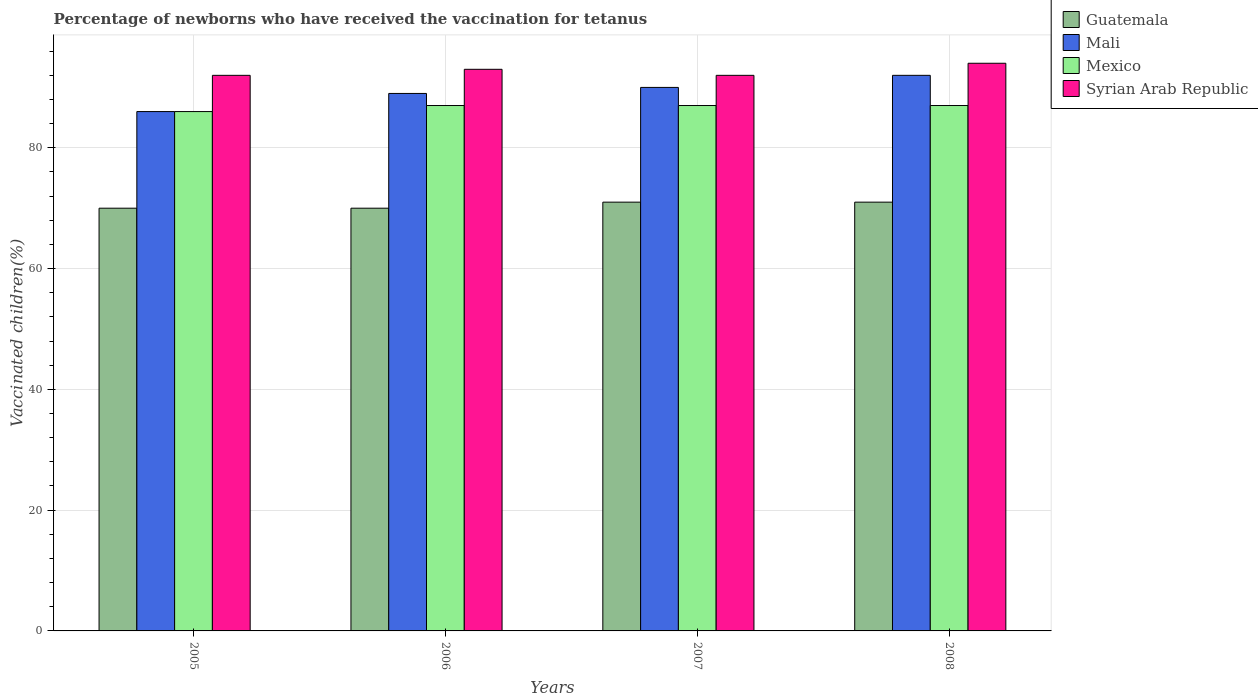How many groups of bars are there?
Keep it short and to the point. 4. Are the number of bars on each tick of the X-axis equal?
Ensure brevity in your answer.  Yes. How many bars are there on the 4th tick from the right?
Your response must be concise. 4. What is the label of the 3rd group of bars from the left?
Give a very brief answer. 2007. What is the percentage of vaccinated children in Guatemala in 2005?
Make the answer very short. 70. Across all years, what is the maximum percentage of vaccinated children in Guatemala?
Provide a short and direct response. 71. Across all years, what is the minimum percentage of vaccinated children in Mexico?
Provide a short and direct response. 86. In which year was the percentage of vaccinated children in Guatemala maximum?
Offer a terse response. 2007. What is the total percentage of vaccinated children in Mexico in the graph?
Keep it short and to the point. 347. What is the difference between the percentage of vaccinated children in Mali in 2007 and the percentage of vaccinated children in Syrian Arab Republic in 2005?
Provide a succinct answer. -2. What is the average percentage of vaccinated children in Mali per year?
Your response must be concise. 89.25. In the year 2007, what is the difference between the percentage of vaccinated children in Mexico and percentage of vaccinated children in Mali?
Give a very brief answer. -3. What is the ratio of the percentage of vaccinated children in Syrian Arab Republic in 2006 to that in 2008?
Ensure brevity in your answer.  0.99. Is the difference between the percentage of vaccinated children in Mexico in 2007 and 2008 greater than the difference between the percentage of vaccinated children in Mali in 2007 and 2008?
Your answer should be very brief. Yes. What is the difference between the highest and the second highest percentage of vaccinated children in Syrian Arab Republic?
Make the answer very short. 1. What is the difference between the highest and the lowest percentage of vaccinated children in Mexico?
Your answer should be very brief. 1. In how many years, is the percentage of vaccinated children in Syrian Arab Republic greater than the average percentage of vaccinated children in Syrian Arab Republic taken over all years?
Offer a terse response. 2. What does the 3rd bar from the left in 2007 represents?
Offer a very short reply. Mexico. What does the 3rd bar from the right in 2007 represents?
Offer a very short reply. Mali. Are all the bars in the graph horizontal?
Your response must be concise. No. Are the values on the major ticks of Y-axis written in scientific E-notation?
Offer a terse response. No. Does the graph contain any zero values?
Offer a terse response. No. Where does the legend appear in the graph?
Offer a very short reply. Top right. How many legend labels are there?
Provide a short and direct response. 4. What is the title of the graph?
Offer a very short reply. Percentage of newborns who have received the vaccination for tetanus. What is the label or title of the Y-axis?
Make the answer very short. Vaccinated children(%). What is the Vaccinated children(%) in Guatemala in 2005?
Your answer should be compact. 70. What is the Vaccinated children(%) in Mali in 2005?
Keep it short and to the point. 86. What is the Vaccinated children(%) in Mexico in 2005?
Offer a terse response. 86. What is the Vaccinated children(%) of Syrian Arab Republic in 2005?
Offer a terse response. 92. What is the Vaccinated children(%) in Guatemala in 2006?
Your answer should be compact. 70. What is the Vaccinated children(%) of Mali in 2006?
Offer a very short reply. 89. What is the Vaccinated children(%) in Mexico in 2006?
Offer a very short reply. 87. What is the Vaccinated children(%) of Syrian Arab Republic in 2006?
Keep it short and to the point. 93. What is the Vaccinated children(%) in Guatemala in 2007?
Offer a terse response. 71. What is the Vaccinated children(%) of Mali in 2007?
Your answer should be very brief. 90. What is the Vaccinated children(%) in Mexico in 2007?
Your response must be concise. 87. What is the Vaccinated children(%) in Syrian Arab Republic in 2007?
Ensure brevity in your answer.  92. What is the Vaccinated children(%) of Guatemala in 2008?
Give a very brief answer. 71. What is the Vaccinated children(%) in Mali in 2008?
Your answer should be very brief. 92. What is the Vaccinated children(%) in Syrian Arab Republic in 2008?
Offer a very short reply. 94. Across all years, what is the maximum Vaccinated children(%) of Guatemala?
Provide a short and direct response. 71. Across all years, what is the maximum Vaccinated children(%) of Mali?
Ensure brevity in your answer.  92. Across all years, what is the maximum Vaccinated children(%) in Syrian Arab Republic?
Provide a short and direct response. 94. Across all years, what is the minimum Vaccinated children(%) in Syrian Arab Republic?
Offer a very short reply. 92. What is the total Vaccinated children(%) of Guatemala in the graph?
Provide a succinct answer. 282. What is the total Vaccinated children(%) of Mali in the graph?
Your response must be concise. 357. What is the total Vaccinated children(%) of Mexico in the graph?
Keep it short and to the point. 347. What is the total Vaccinated children(%) of Syrian Arab Republic in the graph?
Your response must be concise. 371. What is the difference between the Vaccinated children(%) in Guatemala in 2005 and that in 2006?
Give a very brief answer. 0. What is the difference between the Vaccinated children(%) in Mexico in 2005 and that in 2006?
Provide a short and direct response. -1. What is the difference between the Vaccinated children(%) of Syrian Arab Republic in 2005 and that in 2006?
Give a very brief answer. -1. What is the difference between the Vaccinated children(%) in Guatemala in 2005 and that in 2007?
Offer a very short reply. -1. What is the difference between the Vaccinated children(%) in Mexico in 2005 and that in 2007?
Make the answer very short. -1. What is the difference between the Vaccinated children(%) in Mexico in 2005 and that in 2008?
Offer a very short reply. -1. What is the difference between the Vaccinated children(%) of Guatemala in 2006 and that in 2007?
Provide a succinct answer. -1. What is the difference between the Vaccinated children(%) of Mali in 2006 and that in 2007?
Your answer should be very brief. -1. What is the difference between the Vaccinated children(%) of Mali in 2006 and that in 2008?
Your answer should be compact. -3. What is the difference between the Vaccinated children(%) in Syrian Arab Republic in 2006 and that in 2008?
Provide a succinct answer. -1. What is the difference between the Vaccinated children(%) in Guatemala in 2007 and that in 2008?
Provide a short and direct response. 0. What is the difference between the Vaccinated children(%) in Mali in 2007 and that in 2008?
Provide a succinct answer. -2. What is the difference between the Vaccinated children(%) in Guatemala in 2005 and the Vaccinated children(%) in Mexico in 2006?
Keep it short and to the point. -17. What is the difference between the Vaccinated children(%) in Guatemala in 2005 and the Vaccinated children(%) in Syrian Arab Republic in 2006?
Ensure brevity in your answer.  -23. What is the difference between the Vaccinated children(%) of Mali in 2005 and the Vaccinated children(%) of Mexico in 2006?
Provide a succinct answer. -1. What is the difference between the Vaccinated children(%) in Mali in 2005 and the Vaccinated children(%) in Syrian Arab Republic in 2006?
Your response must be concise. -7. What is the difference between the Vaccinated children(%) of Mexico in 2005 and the Vaccinated children(%) of Syrian Arab Republic in 2006?
Ensure brevity in your answer.  -7. What is the difference between the Vaccinated children(%) in Guatemala in 2005 and the Vaccinated children(%) in Mali in 2007?
Ensure brevity in your answer.  -20. What is the difference between the Vaccinated children(%) of Guatemala in 2005 and the Vaccinated children(%) of Mexico in 2007?
Give a very brief answer. -17. What is the difference between the Vaccinated children(%) of Mali in 2005 and the Vaccinated children(%) of Mexico in 2007?
Provide a short and direct response. -1. What is the difference between the Vaccinated children(%) of Mexico in 2005 and the Vaccinated children(%) of Syrian Arab Republic in 2007?
Offer a terse response. -6. What is the difference between the Vaccinated children(%) of Mali in 2005 and the Vaccinated children(%) of Mexico in 2008?
Make the answer very short. -1. What is the difference between the Vaccinated children(%) of Mali in 2005 and the Vaccinated children(%) of Syrian Arab Republic in 2008?
Your answer should be compact. -8. What is the difference between the Vaccinated children(%) in Guatemala in 2006 and the Vaccinated children(%) in Mexico in 2007?
Keep it short and to the point. -17. What is the difference between the Vaccinated children(%) in Guatemala in 2006 and the Vaccinated children(%) in Syrian Arab Republic in 2007?
Make the answer very short. -22. What is the difference between the Vaccinated children(%) of Mali in 2006 and the Vaccinated children(%) of Syrian Arab Republic in 2007?
Give a very brief answer. -3. What is the difference between the Vaccinated children(%) of Guatemala in 2006 and the Vaccinated children(%) of Mexico in 2008?
Provide a succinct answer. -17. What is the difference between the Vaccinated children(%) in Guatemala in 2006 and the Vaccinated children(%) in Syrian Arab Republic in 2008?
Offer a very short reply. -24. What is the difference between the Vaccinated children(%) in Mali in 2006 and the Vaccinated children(%) in Mexico in 2008?
Ensure brevity in your answer.  2. What is the difference between the Vaccinated children(%) in Mali in 2006 and the Vaccinated children(%) in Syrian Arab Republic in 2008?
Make the answer very short. -5. What is the difference between the Vaccinated children(%) in Guatemala in 2007 and the Vaccinated children(%) in Syrian Arab Republic in 2008?
Offer a terse response. -23. What is the difference between the Vaccinated children(%) of Mali in 2007 and the Vaccinated children(%) of Syrian Arab Republic in 2008?
Keep it short and to the point. -4. What is the difference between the Vaccinated children(%) of Mexico in 2007 and the Vaccinated children(%) of Syrian Arab Republic in 2008?
Your answer should be compact. -7. What is the average Vaccinated children(%) in Guatemala per year?
Your answer should be very brief. 70.5. What is the average Vaccinated children(%) of Mali per year?
Keep it short and to the point. 89.25. What is the average Vaccinated children(%) of Mexico per year?
Ensure brevity in your answer.  86.75. What is the average Vaccinated children(%) in Syrian Arab Republic per year?
Your answer should be compact. 92.75. In the year 2005, what is the difference between the Vaccinated children(%) in Guatemala and Vaccinated children(%) in Mali?
Give a very brief answer. -16. In the year 2005, what is the difference between the Vaccinated children(%) of Guatemala and Vaccinated children(%) of Mexico?
Offer a very short reply. -16. In the year 2005, what is the difference between the Vaccinated children(%) of Mali and Vaccinated children(%) of Syrian Arab Republic?
Keep it short and to the point. -6. In the year 2007, what is the difference between the Vaccinated children(%) of Guatemala and Vaccinated children(%) of Mexico?
Provide a short and direct response. -16. In the year 2007, what is the difference between the Vaccinated children(%) of Guatemala and Vaccinated children(%) of Syrian Arab Republic?
Your response must be concise. -21. In the year 2007, what is the difference between the Vaccinated children(%) in Mali and Vaccinated children(%) in Mexico?
Make the answer very short. 3. In the year 2007, what is the difference between the Vaccinated children(%) in Mali and Vaccinated children(%) in Syrian Arab Republic?
Provide a short and direct response. -2. In the year 2008, what is the difference between the Vaccinated children(%) of Guatemala and Vaccinated children(%) of Mali?
Offer a very short reply. -21. In the year 2008, what is the difference between the Vaccinated children(%) of Guatemala and Vaccinated children(%) of Syrian Arab Republic?
Offer a terse response. -23. In the year 2008, what is the difference between the Vaccinated children(%) of Mali and Vaccinated children(%) of Mexico?
Offer a very short reply. 5. In the year 2008, what is the difference between the Vaccinated children(%) in Mexico and Vaccinated children(%) in Syrian Arab Republic?
Keep it short and to the point. -7. What is the ratio of the Vaccinated children(%) of Guatemala in 2005 to that in 2006?
Keep it short and to the point. 1. What is the ratio of the Vaccinated children(%) of Mali in 2005 to that in 2006?
Ensure brevity in your answer.  0.97. What is the ratio of the Vaccinated children(%) of Mexico in 2005 to that in 2006?
Your answer should be compact. 0.99. What is the ratio of the Vaccinated children(%) of Syrian Arab Republic in 2005 to that in 2006?
Ensure brevity in your answer.  0.99. What is the ratio of the Vaccinated children(%) in Guatemala in 2005 to that in 2007?
Offer a very short reply. 0.99. What is the ratio of the Vaccinated children(%) of Mali in 2005 to that in 2007?
Offer a terse response. 0.96. What is the ratio of the Vaccinated children(%) of Mexico in 2005 to that in 2007?
Provide a succinct answer. 0.99. What is the ratio of the Vaccinated children(%) in Syrian Arab Republic in 2005 to that in 2007?
Provide a short and direct response. 1. What is the ratio of the Vaccinated children(%) of Guatemala in 2005 to that in 2008?
Offer a very short reply. 0.99. What is the ratio of the Vaccinated children(%) of Mali in 2005 to that in 2008?
Provide a short and direct response. 0.93. What is the ratio of the Vaccinated children(%) in Syrian Arab Republic in 2005 to that in 2008?
Your response must be concise. 0.98. What is the ratio of the Vaccinated children(%) in Guatemala in 2006 to that in 2007?
Provide a short and direct response. 0.99. What is the ratio of the Vaccinated children(%) of Mali in 2006 to that in 2007?
Provide a succinct answer. 0.99. What is the ratio of the Vaccinated children(%) in Mexico in 2006 to that in 2007?
Ensure brevity in your answer.  1. What is the ratio of the Vaccinated children(%) in Syrian Arab Republic in 2006 to that in 2007?
Offer a very short reply. 1.01. What is the ratio of the Vaccinated children(%) in Guatemala in 2006 to that in 2008?
Provide a succinct answer. 0.99. What is the ratio of the Vaccinated children(%) in Mali in 2006 to that in 2008?
Give a very brief answer. 0.97. What is the ratio of the Vaccinated children(%) of Mali in 2007 to that in 2008?
Your answer should be very brief. 0.98. What is the ratio of the Vaccinated children(%) in Syrian Arab Republic in 2007 to that in 2008?
Give a very brief answer. 0.98. What is the difference between the highest and the lowest Vaccinated children(%) of Syrian Arab Republic?
Provide a succinct answer. 2. 